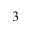Convert formula to latex. <formula><loc_0><loc_0><loc_500><loc_500>^ { 3 }</formula> 